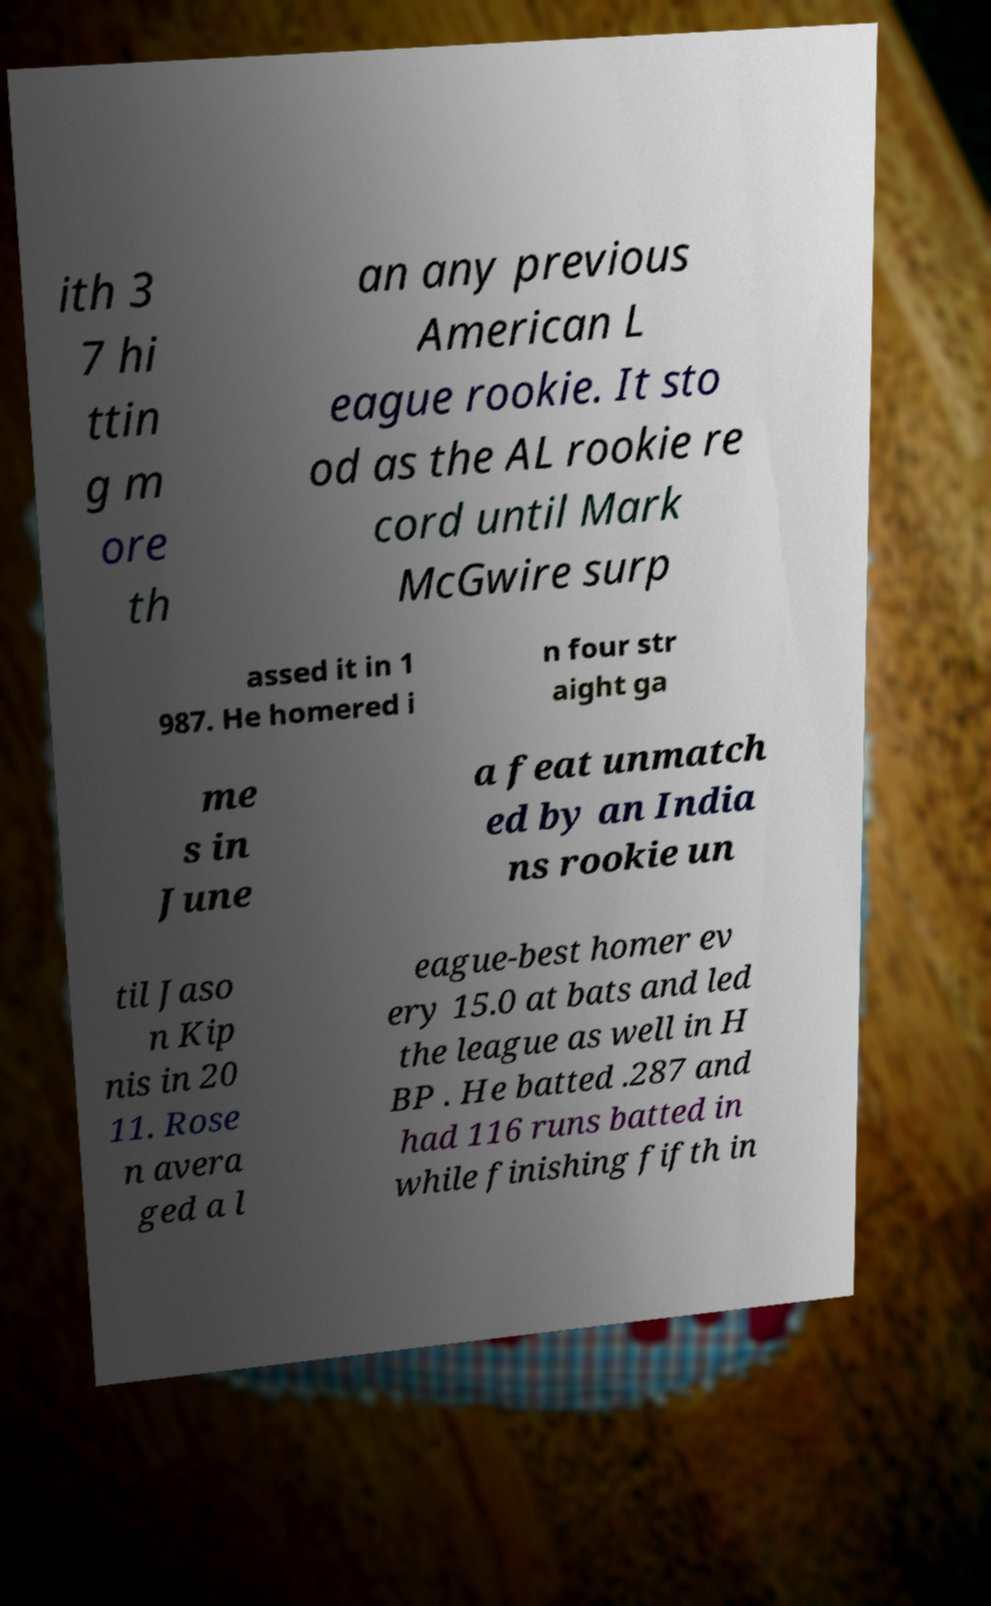Can you read and provide the text displayed in the image?This photo seems to have some interesting text. Can you extract and type it out for me? ith 3 7 hi ttin g m ore th an any previous American L eague rookie. It sto od as the AL rookie re cord until Mark McGwire surp assed it in 1 987. He homered i n four str aight ga me s in June a feat unmatch ed by an India ns rookie un til Jaso n Kip nis in 20 11. Rose n avera ged a l eague-best homer ev ery 15.0 at bats and led the league as well in H BP . He batted .287 and had 116 runs batted in while finishing fifth in 